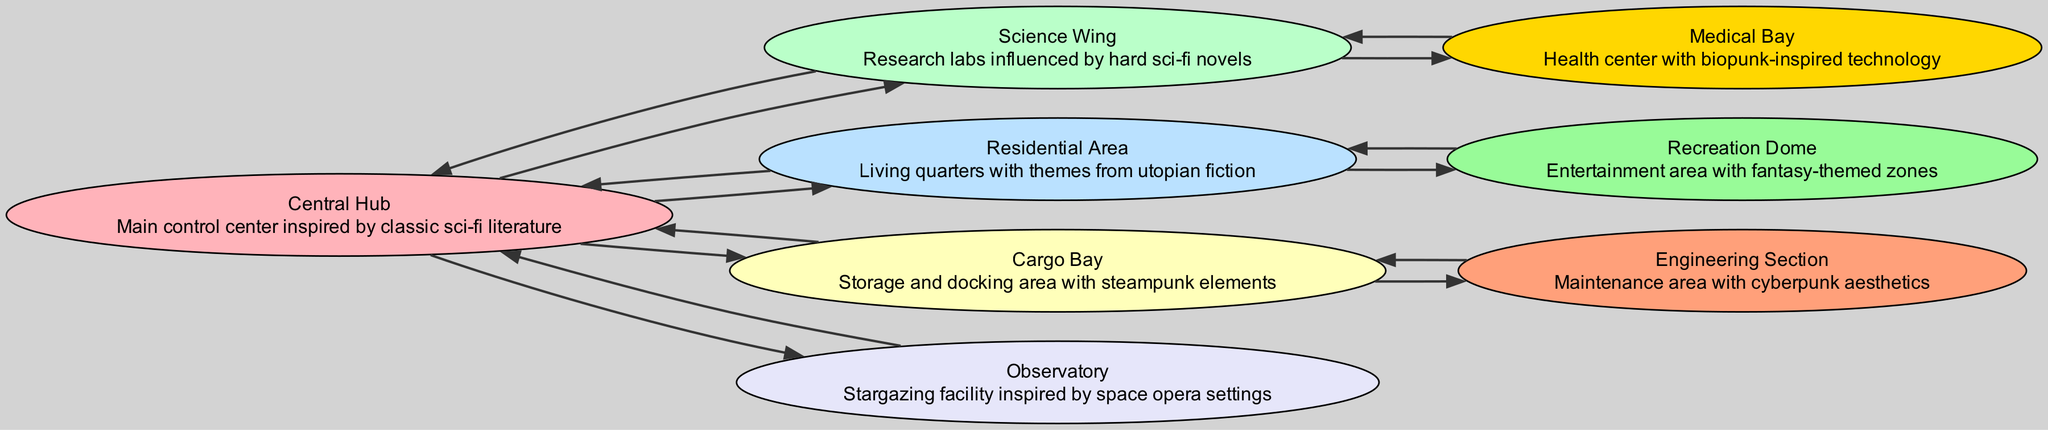How many nodes are in the diagram? By counting each distinct area represented in the diagram, we identify the following nodes: Central Hub, Science Wing, Residential Area, Cargo Bay, Observatory, Medical Bay, Recreation Dome, and Engineering Section. This totals to 8 nodes.
Answer: 8 What is the theme of the Recreation Dome? The diagram indicates that the Recreation Dome is characterized by entertainment areas with fantasy-themed zones. This description provides clear insight into its genre inspiration.
Answer: Fantasy Which area is connected to both the Central Hub and the Medical Bay? To find the area connected to both of these nodes, we observe that the Medical Bay has only one connection, which is to the Science Wing. The Science Wing is directly connected to the Central Hub, leading us to confirm that the Science Wing is the answer.
Answer: Science Wing What aesthetic influences the Engineering Section? Referring to the description in the diagram, we see that the Engineering Section is influenced by cyberpunk aesthetics. It clearly states the theme associated with this part of the space station.
Answer: Cyberpunk Which area has steampunk elements? The diagram specifies that the Cargo Bay incorporates steampunk elements in its design. This unique blend of aesthetics stands out in its description.
Answer: Cargo Bay What connects the Residential Area to the Recreation Dome? The connections outlined in the diagram show that the Residential Area links directly to the Recreation Dome without any intermediary nodes. This direct connection implies a straightforward relationship.
Answer: Direct connection Which areas are exclusively connected to the Central Hub? Analyzing the connections, we see that four areas are linked exclusively to the Central Hub: the Science Wing, Residential Area, Cargo Bay, and Observatory. This reveals the central role of the hub in the station's structure.
Answer: Four areas From which area can one access the Science Wing? According to the connections given in the diagram, the only area that provides access to the Science Wing is the Central Hub. This relationship highlights the importance of the hub in facilitating access to various sections.
Answer: Central Hub Which area is solely dedicated to health? The Medical Bay is explicitly described in the diagram as the health center, indicating its sole focus on health-related purposes within the space station's structure.
Answer: Medical Bay 